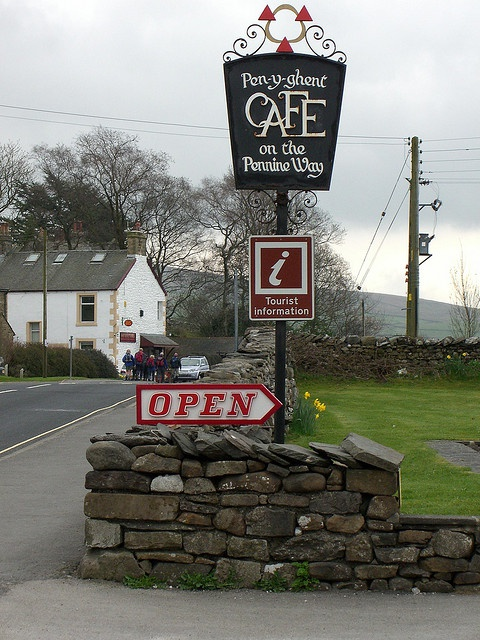Describe the objects in this image and their specific colors. I can see car in white, darkgray, black, gray, and lightgray tones, people in white, black, maroon, and gray tones, people in white, black, gray, navy, and blue tones, people in white, black, maroon, gray, and navy tones, and people in white, black, maroon, gray, and navy tones in this image. 